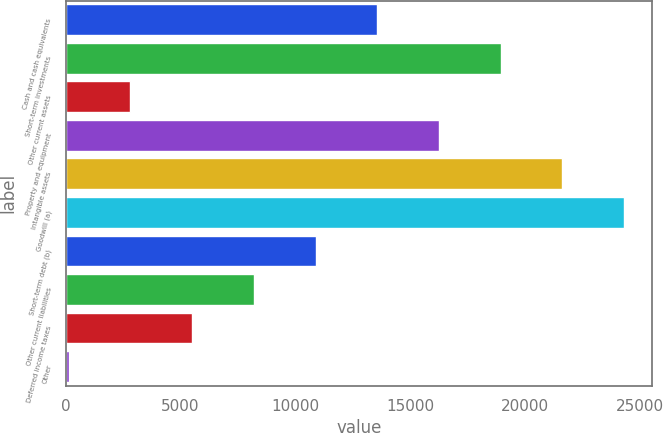Convert chart. <chart><loc_0><loc_0><loc_500><loc_500><bar_chart><fcel>Cash and cash equivalents<fcel>Short-term investments<fcel>Other current assets<fcel>Property and equipment<fcel>Intangible assets<fcel>Goodwill (a)<fcel>Short-term debt (b)<fcel>Other current liabilities<fcel>Deferred income taxes<fcel>Other<nl><fcel>13570<fcel>18945.6<fcel>2818.8<fcel>16257.8<fcel>21633.4<fcel>24321.2<fcel>10882.2<fcel>8194.4<fcel>5506.6<fcel>131<nl></chart> 